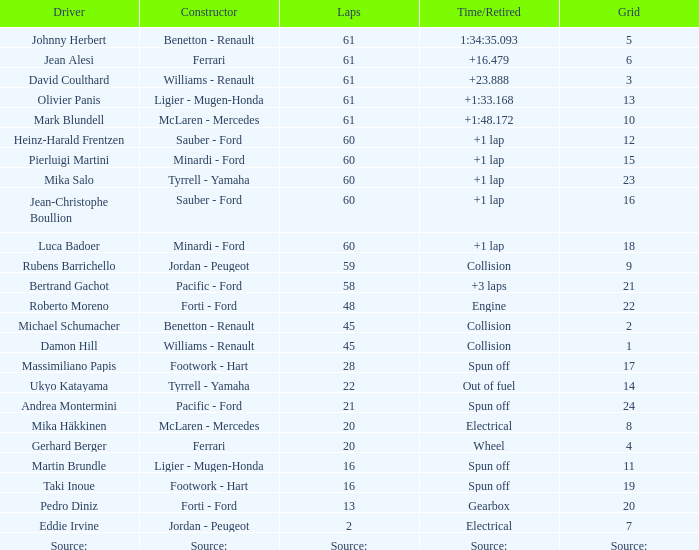What is the number of laps jean-christophe boullion has with a time/retired of an extra lap? 60.0. 